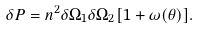Convert formula to latex. <formula><loc_0><loc_0><loc_500><loc_500>\delta P = n ^ { 2 } \delta \Omega _ { 1 } \delta \Omega _ { 2 } [ 1 + \omega ( \theta ) ] .</formula> 